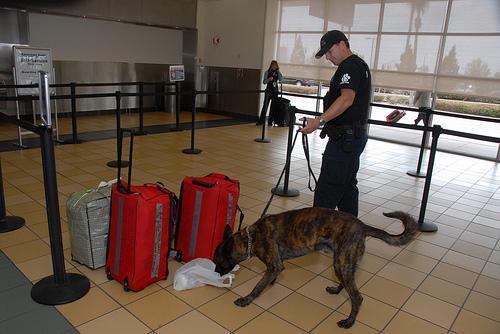How many red suitcaces are in front of the dog?
Give a very brief answer. 2. 